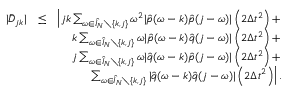Convert formula to latex. <formula><loc_0><loc_0><loc_500><loc_500>\begin{array} { r l r } { | \bar { D } _ { j k } | } & { \leq } & { \left | j k \sum _ { \omega \in \hat { I } _ { N } \ \{ k , j \} } \omega ^ { 2 } | \hat { p } ( \omega - k ) \hat { p } ( j - \omega ) | \left ( 2 \Delta t ^ { 2 } \right ) + } \\ & { k \sum _ { \omega \in \hat { I } _ { N } \ \{ k , j \} } \omega | \hat { p } ( \omega - k ) \hat { q } ( j - \omega ) | \left ( 2 \Delta t ^ { 2 } \right ) + } \\ & { j \sum _ { \omega \in \hat { I } _ { N } \ \{ k , j \} } \omega | \hat { q } ( \omega - k ) \hat { p } ( j - \omega ) | \left ( 2 \Delta t ^ { 2 } \right ) + } \\ & { \sum _ { \omega \in \hat { I } _ { N } \ \{ k , j \} } | \hat { q } ( \omega - k ) \hat { q } ( j - \omega ) | \left ( 2 \Delta t ^ { 2 } \right ) \right | . } \end{array}</formula> 